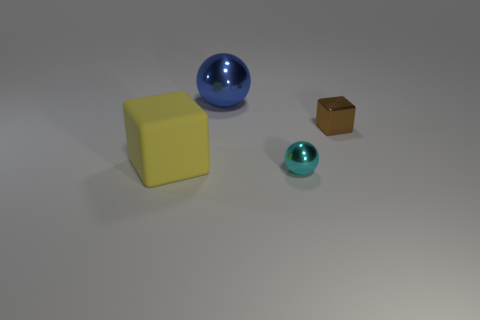Add 4 large yellow things. How many objects exist? 8 Add 3 small metal spheres. How many small metal spheres exist? 4 Subtract 0 red blocks. How many objects are left? 4 Subtract all big metal balls. Subtract all small cyan matte blocks. How many objects are left? 3 Add 4 blue metal objects. How many blue metal objects are left? 5 